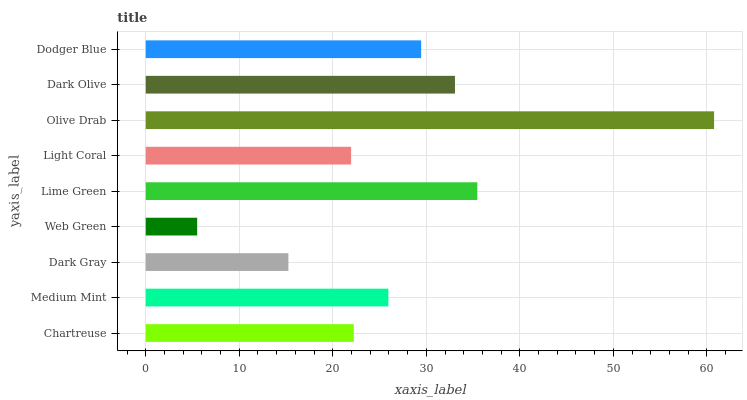Is Web Green the minimum?
Answer yes or no. Yes. Is Olive Drab the maximum?
Answer yes or no. Yes. Is Medium Mint the minimum?
Answer yes or no. No. Is Medium Mint the maximum?
Answer yes or no. No. Is Medium Mint greater than Chartreuse?
Answer yes or no. Yes. Is Chartreuse less than Medium Mint?
Answer yes or no. Yes. Is Chartreuse greater than Medium Mint?
Answer yes or no. No. Is Medium Mint less than Chartreuse?
Answer yes or no. No. Is Medium Mint the high median?
Answer yes or no. Yes. Is Medium Mint the low median?
Answer yes or no. Yes. Is Chartreuse the high median?
Answer yes or no. No. Is Light Coral the low median?
Answer yes or no. No. 